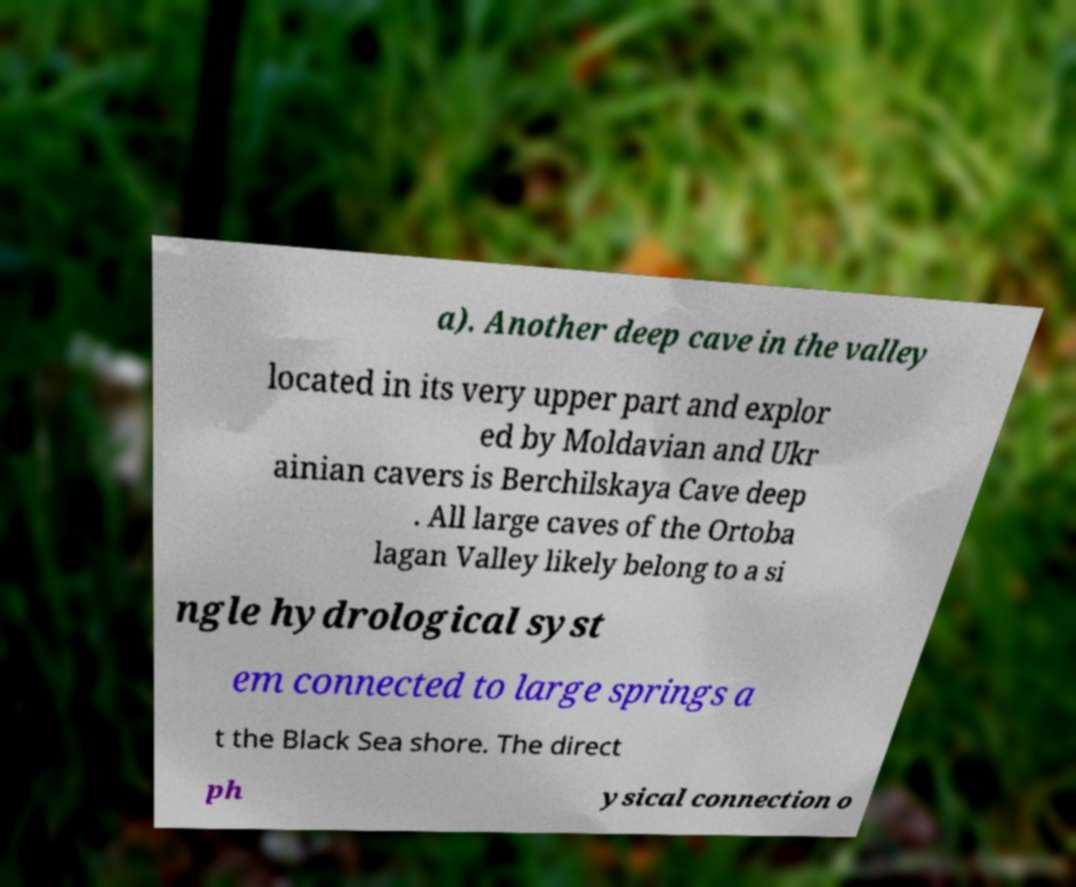Could you extract and type out the text from this image? a). Another deep cave in the valley located in its very upper part and explor ed by Moldavian and Ukr ainian cavers is Berchilskaya Cave deep . All large caves of the Ortoba lagan Valley likely belong to a si ngle hydrological syst em connected to large springs a t the Black Sea shore. The direct ph ysical connection o 